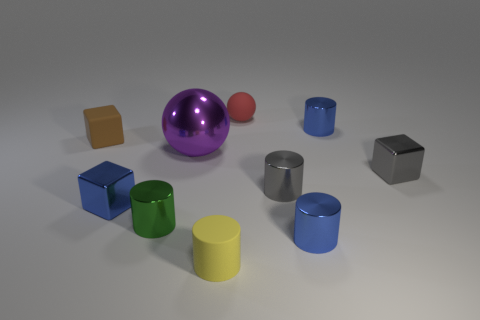Subtract all green cylinders. How many cylinders are left? 4 Subtract all green cylinders. How many cylinders are left? 4 Subtract all cyan cylinders. Subtract all red cubes. How many cylinders are left? 5 Subtract all balls. How many objects are left? 8 Subtract 0 cyan balls. How many objects are left? 10 Subtract all brown rubber things. Subtract all big metallic things. How many objects are left? 8 Add 4 rubber cubes. How many rubber cubes are left? 5 Add 8 large purple metallic balls. How many large purple metallic balls exist? 9 